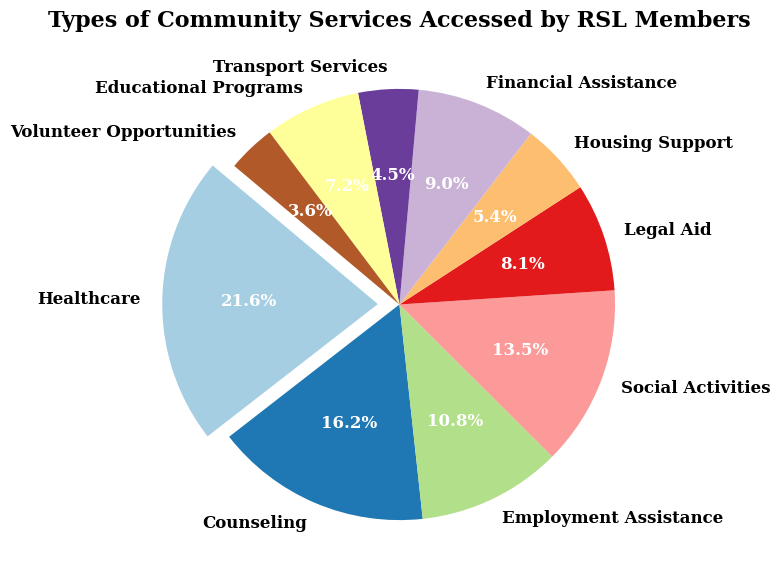What percentage of members accessed Healthcare services? The pie chart will show a segment labeled "Healthcare," with an attached percentage value. By observing this percentage, one can see the proportion of members accessing Healthcare services relative to the total.
Answer: 26.7% Which service is accessed by the most members? By finding the largest segment in the pie chart, which will be distinct due to its size and possibly an exploded wedge, you can identify which service is the most accessed.
Answer: Healthcare What is the combined percentage of members accessing Employment Assistance and Social Activities? First, find the percentage values for Employment Assistance and Social Activities in the chart. Then, add these percentages together to get the combined value.
Answer: 30% How many more members accessed Counseling services compared to Housing Support services? From the pie chart, identify the number of members for Counseling and Housing Support. Subtract the number of Housing Support members from Counseling members to get the difference.
Answer: 60 Which two services have almost equal representation? Look for segments in the pie chart that are approximately the same size, which will also have nearly the same percentage labels.
Answer: Legal Aid and Educational Programs What percentage of members accessed services related to financial and housing support combined? Find the segments for Financial Assistance and Housing Support, then add their percentage values together.
Answer: 16.7% How does the percentage of members accessing Transport Services compare to those accessing Volunteer Opportunities? Note the percentage values of the Transport Services and Volunteer Opportunities segments and directly compare them.
Answer: Transport Services is higher If 10 more members started accessing Educational Programs, what would be the new percentage for Educational Programs? Calculate the new total number of members (maximum 560) and the updated number for Educational Programs (40+10=50). New percentage = (50/560) * 100
Answer: 8.9% What is the least accessed service? Identify the smallest segment in the pie chart, which represents the least accessed service.
Answer: Volunteer Opportunities 